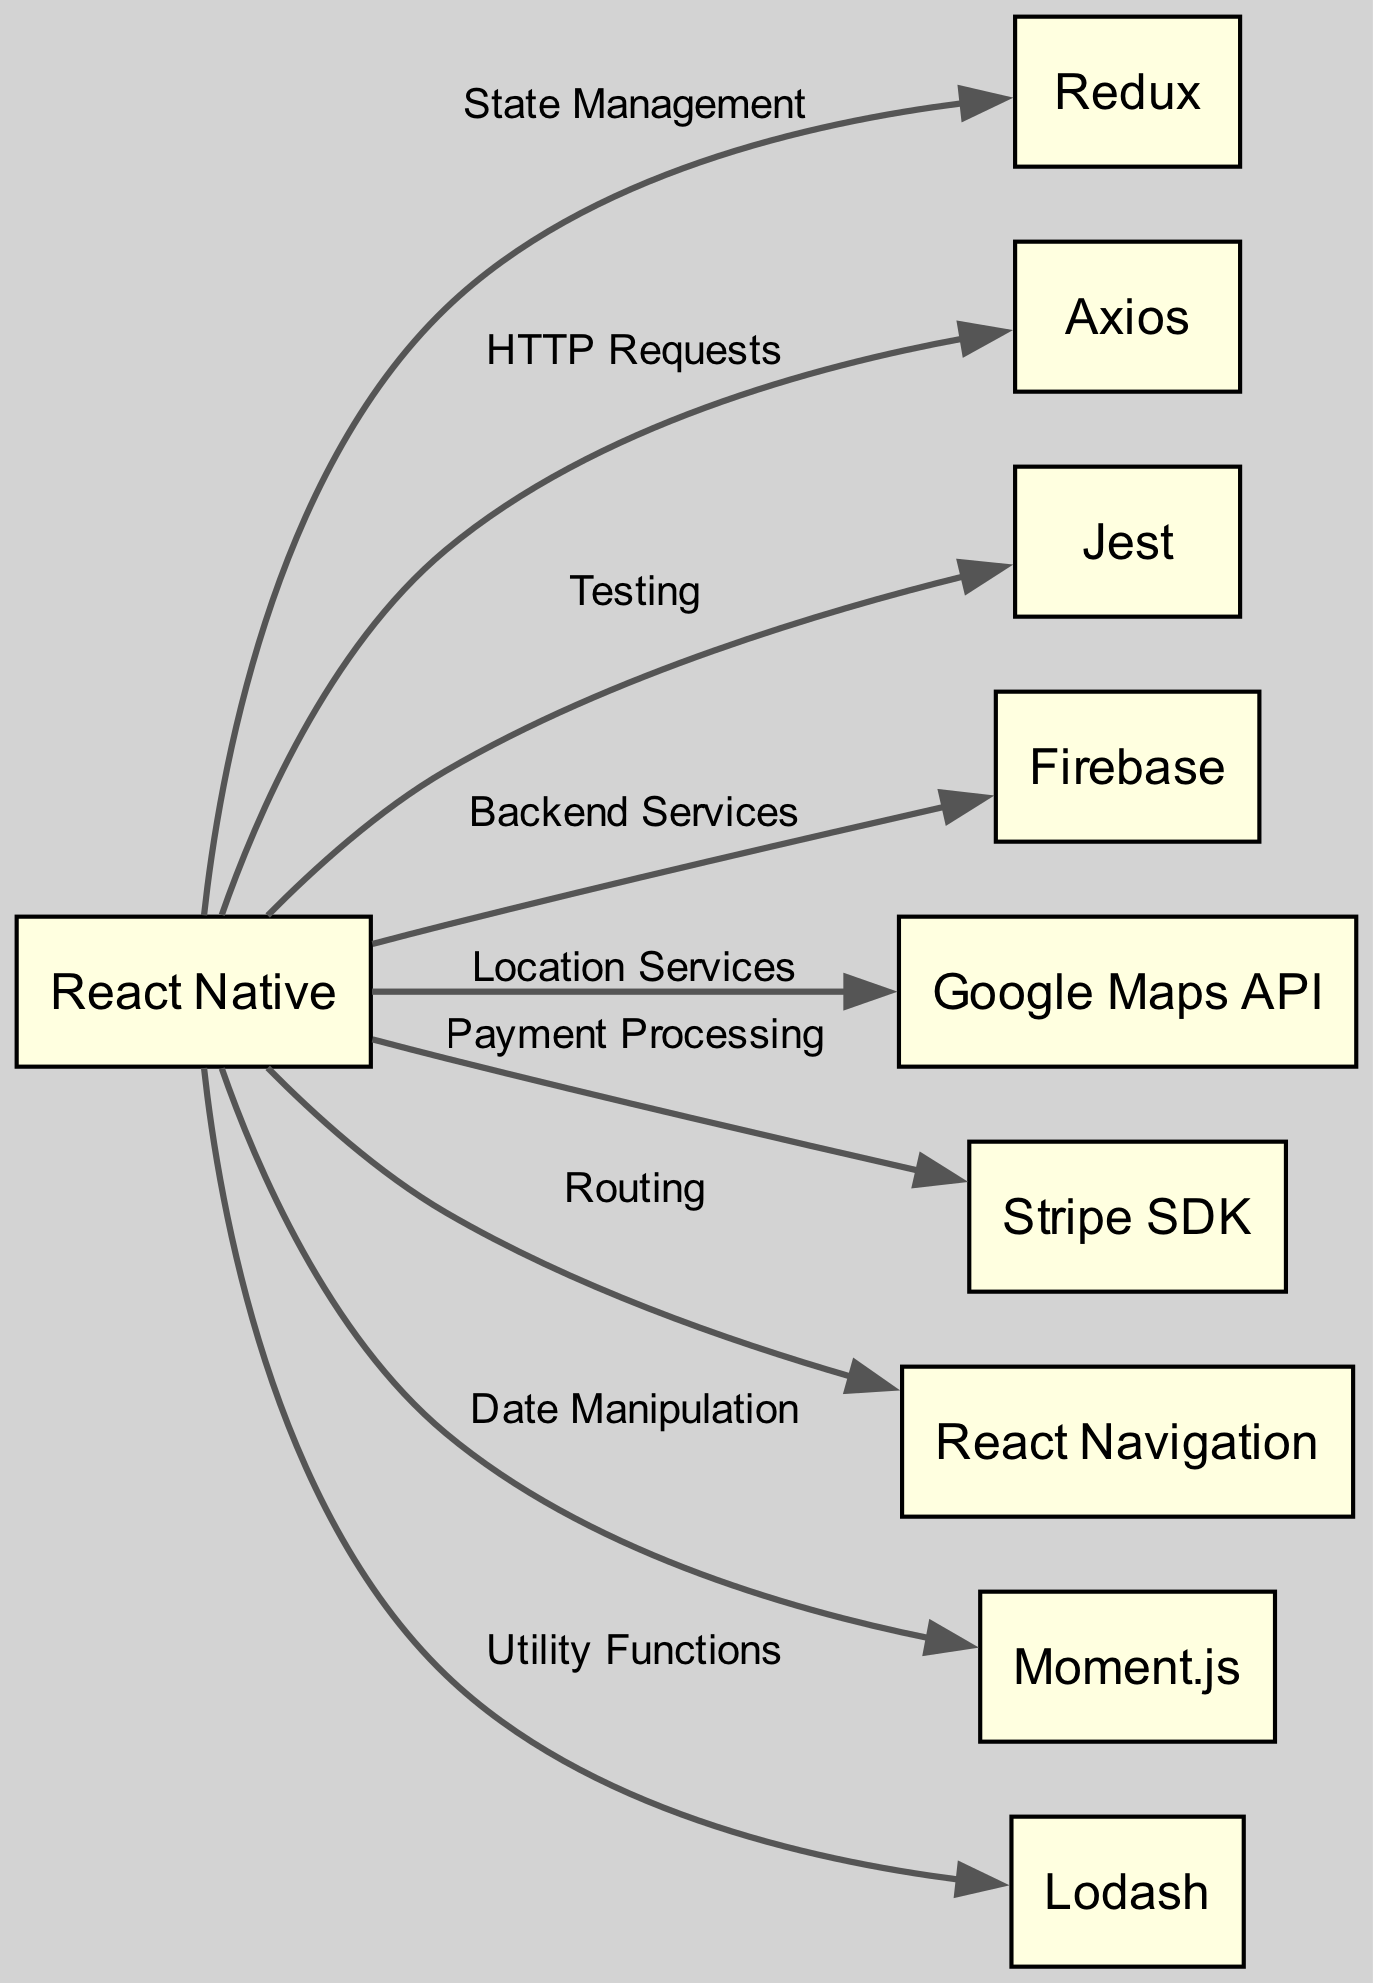What is the total number of nodes in the graph? To find the total number of nodes, we simply count each unique entry in the "nodes" list of the data provided. There are 10 unique nodes listed.
Answer: 10 Which library is used for state management? The directed edge labeled "State Management" originates from "React Native" and points to "Redux." Therefore, Redux is the library for state management.
Answer: Redux How many libraries does React Native connect to directly? By examining the edges originating from "React Native," we find that there are 9 directed edges leading to different libraries, indicating that React Native connects to 9 libraries directly.
Answer: 9 What functionality does the arrow between React Native and Jest represent? The arrow between "React Native" and "Jest" has a label stating "Testing." This indicates that Jest is used for testing in the context of the project related to React Native.
Answer: Testing Which library provides payment processing functionality? The directional edge from "React Native" to "Stripe SDK" has the label "Payment Processing." Therefore, Stripe SDK is the library that provides payment processing functionality.
Answer: Stripe SDK What is the relationship between React Native and Firebase? The edge from "React Native" to "Firebase" shows that the connection is labeled "Backend Services," indicating that Firebase serves as the backend service for the project using React Native.
Answer: Backend Services What is the dependency of Moment.js? The directed edge indicates that "Moment.js" is connected to "React Native." Therefore, Moment.js depends on React Native in the project setup.
Answer: React Native Which two libraries are related to the location services and payment processing? "Google Maps API" is connected to React Native through "Location Services," and "Stripe SDK" is connected to React Native through "Payment Processing." Both libraries serve different functions tied to React Native.
Answer: Google Maps API and Stripe SDK 